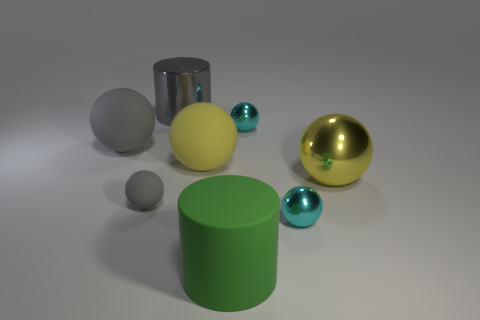How many gray spheres must be subtracted to get 1 gray spheres? 1 Subtract all large yellow matte spheres. How many spheres are left? 5 Add 1 green cylinders. How many objects exist? 9 Subtract all cyan balls. How many balls are left? 4 Subtract all cylinders. How many objects are left? 6 Subtract 1 cylinders. How many cylinders are left? 1 Subtract all gray cylinders. How many cyan spheres are left? 2 Subtract 0 red cylinders. How many objects are left? 8 Subtract all red cylinders. Subtract all red cubes. How many cylinders are left? 2 Subtract all blue balls. Subtract all small rubber things. How many objects are left? 7 